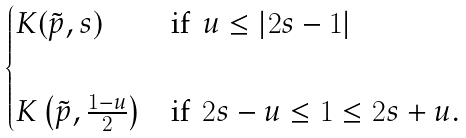Convert formula to latex. <formula><loc_0><loc_0><loc_500><loc_500>\begin{cases} K ( \tilde { p } , s ) & \text {if\, $u\leq|2s-1|$} \\ \\ K \left ( \tilde { p } , \frac { 1 - u } { 2 } \right ) & \text {if\, $2s-u\leq 1\leq 2s+u$.} \end{cases}</formula> 